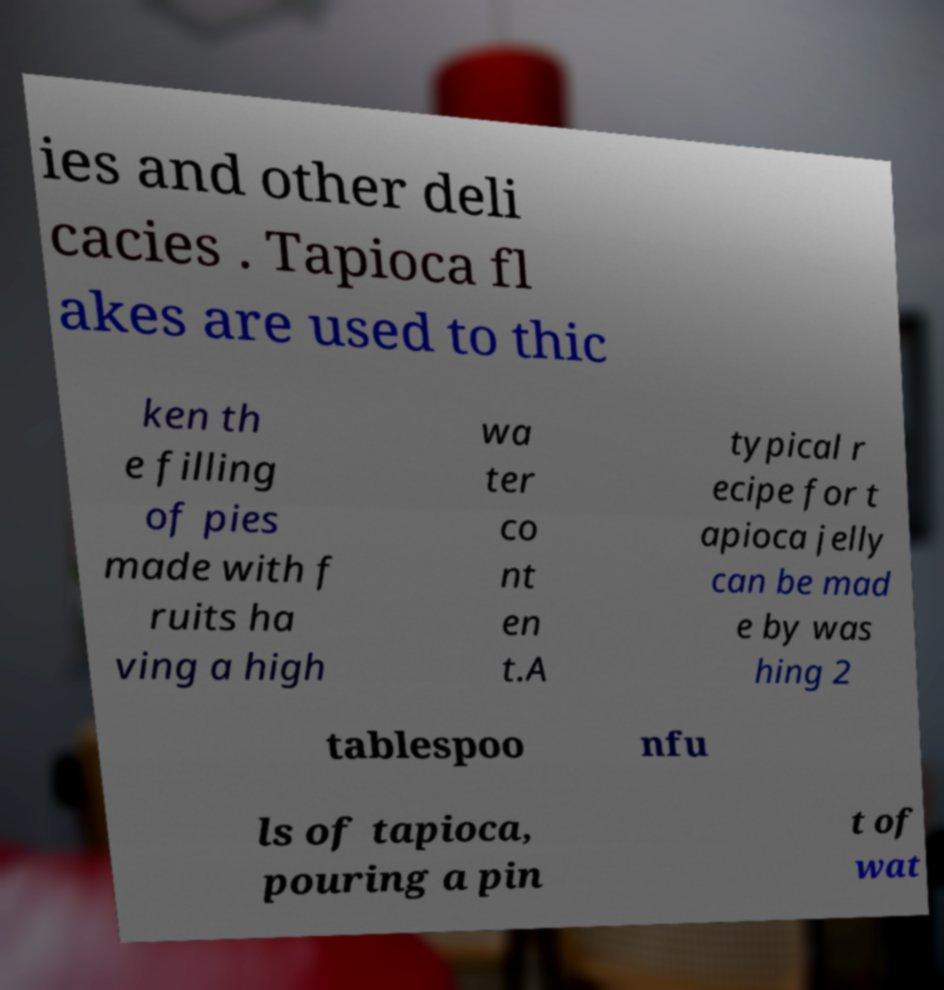Can you accurately transcribe the text from the provided image for me? ies and other deli cacies . Tapioca fl akes are used to thic ken th e filling of pies made with f ruits ha ving a high wa ter co nt en t.A typical r ecipe for t apioca jelly can be mad e by was hing 2 tablespoo nfu ls of tapioca, pouring a pin t of wat 